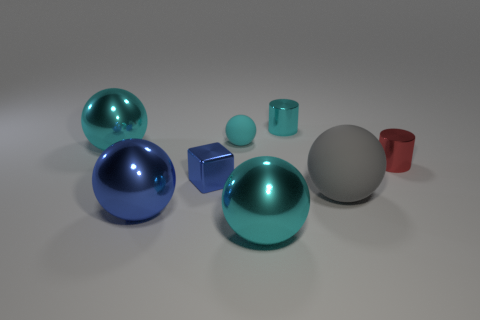What could be the purpose of arranging these objects like this? The arrangement of these objects may serve several purposes. It could be a visual study of form and color, an examination of different materials and their reflective properties under uniform lighting, or it might be a setup designed to train image recognition algorithms by providing a variety of shapes and textures. 